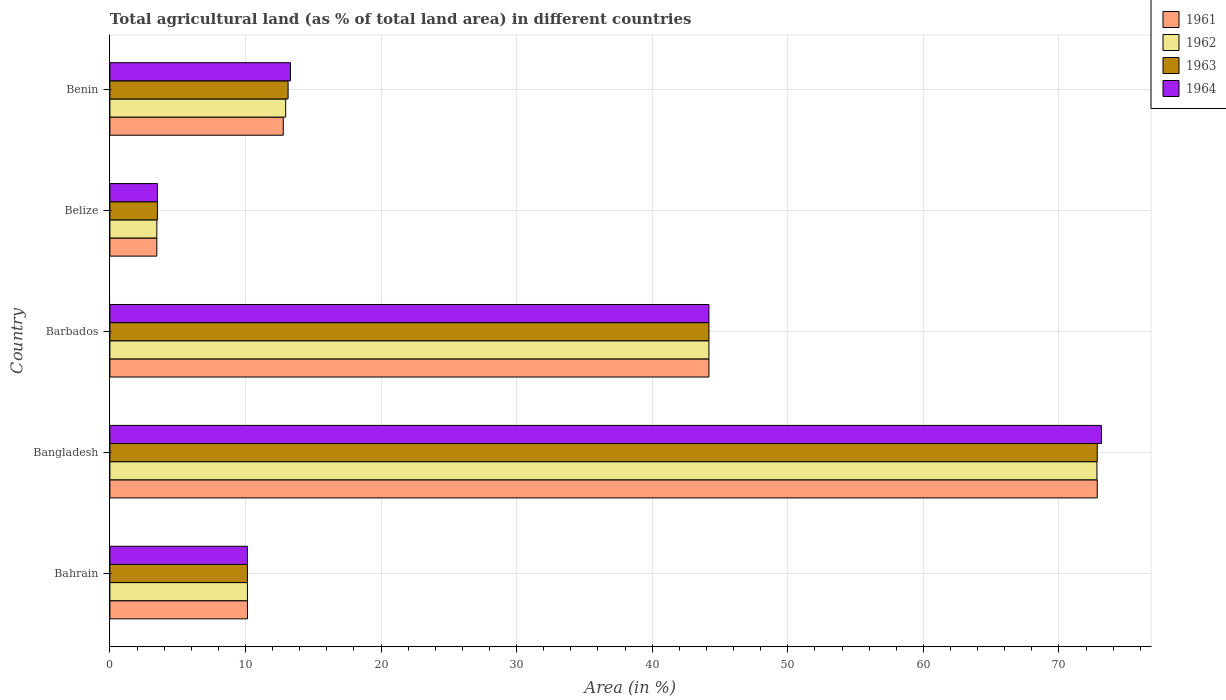Are the number of bars per tick equal to the number of legend labels?
Your answer should be compact. Yes. How many bars are there on the 3rd tick from the top?
Ensure brevity in your answer.  4. How many bars are there on the 3rd tick from the bottom?
Your answer should be compact. 4. What is the label of the 5th group of bars from the top?
Keep it short and to the point. Bahrain. In how many cases, is the number of bars for a given country not equal to the number of legend labels?
Give a very brief answer. 0. What is the percentage of agricultural land in 1962 in Belize?
Ensure brevity in your answer.  3.46. Across all countries, what is the maximum percentage of agricultural land in 1963?
Offer a terse response. 72.83. Across all countries, what is the minimum percentage of agricultural land in 1963?
Keep it short and to the point. 3.51. In which country was the percentage of agricultural land in 1964 minimum?
Offer a very short reply. Belize. What is the total percentage of agricultural land in 1964 in the graph?
Provide a succinct answer. 144.29. What is the difference between the percentage of agricultural land in 1962 in Bangladesh and that in Benin?
Provide a succinct answer. 59.84. What is the difference between the percentage of agricultural land in 1961 in Bahrain and the percentage of agricultural land in 1964 in Benin?
Your answer should be compact. -3.18. What is the average percentage of agricultural land in 1962 per country?
Your answer should be compact. 28.71. What is the difference between the percentage of agricultural land in 1962 and percentage of agricultural land in 1964 in Bahrain?
Make the answer very short. 0. What is the ratio of the percentage of agricultural land in 1964 in Bangladesh to that in Belize?
Ensure brevity in your answer.  20.85. Is the percentage of agricultural land in 1964 in Bangladesh less than that in Barbados?
Provide a short and direct response. No. Is the difference between the percentage of agricultural land in 1962 in Bahrain and Belize greater than the difference between the percentage of agricultural land in 1964 in Bahrain and Belize?
Offer a terse response. Yes. What is the difference between the highest and the second highest percentage of agricultural land in 1964?
Offer a terse response. 28.95. What is the difference between the highest and the lowest percentage of agricultural land in 1964?
Provide a succinct answer. 69.63. In how many countries, is the percentage of agricultural land in 1962 greater than the average percentage of agricultural land in 1962 taken over all countries?
Keep it short and to the point. 2. What does the 1st bar from the bottom in Barbados represents?
Ensure brevity in your answer.  1961. Is it the case that in every country, the sum of the percentage of agricultural land in 1962 and percentage of agricultural land in 1963 is greater than the percentage of agricultural land in 1961?
Keep it short and to the point. Yes. What is the difference between two consecutive major ticks on the X-axis?
Provide a succinct answer. 10. Does the graph contain any zero values?
Keep it short and to the point. No. Where does the legend appear in the graph?
Provide a short and direct response. Top right. How are the legend labels stacked?
Give a very brief answer. Vertical. What is the title of the graph?
Ensure brevity in your answer.  Total agricultural land (as % of total land area) in different countries. Does "1964" appear as one of the legend labels in the graph?
Provide a succinct answer. Yes. What is the label or title of the X-axis?
Offer a very short reply. Area (in %). What is the Area (in %) of 1961 in Bahrain?
Your answer should be very brief. 10.14. What is the Area (in %) of 1962 in Bahrain?
Ensure brevity in your answer.  10.14. What is the Area (in %) of 1963 in Bahrain?
Provide a succinct answer. 10.14. What is the Area (in %) of 1964 in Bahrain?
Your answer should be very brief. 10.14. What is the Area (in %) of 1961 in Bangladesh?
Make the answer very short. 72.83. What is the Area (in %) of 1962 in Bangladesh?
Provide a succinct answer. 72.8. What is the Area (in %) of 1963 in Bangladesh?
Give a very brief answer. 72.83. What is the Area (in %) in 1964 in Bangladesh?
Provide a succinct answer. 73.14. What is the Area (in %) of 1961 in Barbados?
Make the answer very short. 44.19. What is the Area (in %) of 1962 in Barbados?
Keep it short and to the point. 44.19. What is the Area (in %) in 1963 in Barbados?
Offer a terse response. 44.19. What is the Area (in %) of 1964 in Barbados?
Your answer should be compact. 44.19. What is the Area (in %) of 1961 in Belize?
Give a very brief answer. 3.46. What is the Area (in %) in 1962 in Belize?
Offer a terse response. 3.46. What is the Area (in %) of 1963 in Belize?
Provide a short and direct response. 3.51. What is the Area (in %) of 1964 in Belize?
Give a very brief answer. 3.51. What is the Area (in %) in 1961 in Benin?
Your response must be concise. 12.79. What is the Area (in %) in 1962 in Benin?
Make the answer very short. 12.97. What is the Area (in %) in 1963 in Benin?
Your answer should be compact. 13.14. What is the Area (in %) in 1964 in Benin?
Make the answer very short. 13.32. Across all countries, what is the maximum Area (in %) in 1961?
Your answer should be very brief. 72.83. Across all countries, what is the maximum Area (in %) of 1962?
Your response must be concise. 72.8. Across all countries, what is the maximum Area (in %) of 1963?
Offer a terse response. 72.83. Across all countries, what is the maximum Area (in %) of 1964?
Provide a short and direct response. 73.14. Across all countries, what is the minimum Area (in %) of 1961?
Your answer should be very brief. 3.46. Across all countries, what is the minimum Area (in %) of 1962?
Offer a terse response. 3.46. Across all countries, what is the minimum Area (in %) in 1963?
Give a very brief answer. 3.51. Across all countries, what is the minimum Area (in %) of 1964?
Ensure brevity in your answer.  3.51. What is the total Area (in %) of 1961 in the graph?
Keep it short and to the point. 143.41. What is the total Area (in %) of 1962 in the graph?
Provide a succinct answer. 143.56. What is the total Area (in %) in 1963 in the graph?
Offer a very short reply. 143.81. What is the total Area (in %) in 1964 in the graph?
Provide a succinct answer. 144.29. What is the difference between the Area (in %) of 1961 in Bahrain and that in Bangladesh?
Provide a short and direct response. -62.68. What is the difference between the Area (in %) of 1962 in Bahrain and that in Bangladesh?
Offer a very short reply. -62.66. What is the difference between the Area (in %) in 1963 in Bahrain and that in Bangladesh?
Offer a very short reply. -62.68. What is the difference between the Area (in %) in 1964 in Bahrain and that in Bangladesh?
Give a very brief answer. -62.99. What is the difference between the Area (in %) in 1961 in Bahrain and that in Barbados?
Give a very brief answer. -34.04. What is the difference between the Area (in %) in 1962 in Bahrain and that in Barbados?
Keep it short and to the point. -34.04. What is the difference between the Area (in %) of 1963 in Bahrain and that in Barbados?
Your answer should be compact. -34.04. What is the difference between the Area (in %) of 1964 in Bahrain and that in Barbados?
Give a very brief answer. -34.04. What is the difference between the Area (in %) in 1961 in Bahrain and that in Belize?
Ensure brevity in your answer.  6.68. What is the difference between the Area (in %) in 1962 in Bahrain and that in Belize?
Keep it short and to the point. 6.68. What is the difference between the Area (in %) in 1963 in Bahrain and that in Belize?
Your answer should be very brief. 6.64. What is the difference between the Area (in %) of 1964 in Bahrain and that in Belize?
Ensure brevity in your answer.  6.64. What is the difference between the Area (in %) in 1961 in Bahrain and that in Benin?
Your response must be concise. -2.64. What is the difference between the Area (in %) of 1962 in Bahrain and that in Benin?
Your response must be concise. -2.82. What is the difference between the Area (in %) of 1963 in Bahrain and that in Benin?
Offer a terse response. -3. What is the difference between the Area (in %) in 1964 in Bahrain and that in Benin?
Provide a short and direct response. -3.18. What is the difference between the Area (in %) in 1961 in Bangladesh and that in Barbados?
Ensure brevity in your answer.  28.64. What is the difference between the Area (in %) in 1962 in Bangladesh and that in Barbados?
Offer a terse response. 28.62. What is the difference between the Area (in %) in 1963 in Bangladesh and that in Barbados?
Your answer should be compact. 28.64. What is the difference between the Area (in %) in 1964 in Bangladesh and that in Barbados?
Offer a very short reply. 28.95. What is the difference between the Area (in %) of 1961 in Bangladesh and that in Belize?
Your answer should be compact. 69.36. What is the difference between the Area (in %) in 1962 in Bangladesh and that in Belize?
Your response must be concise. 69.34. What is the difference between the Area (in %) in 1963 in Bangladesh and that in Belize?
Offer a terse response. 69.32. What is the difference between the Area (in %) in 1964 in Bangladesh and that in Belize?
Keep it short and to the point. 69.63. What is the difference between the Area (in %) of 1961 in Bangladesh and that in Benin?
Offer a terse response. 60.04. What is the difference between the Area (in %) of 1962 in Bangladesh and that in Benin?
Your answer should be very brief. 59.84. What is the difference between the Area (in %) in 1963 in Bangladesh and that in Benin?
Make the answer very short. 59.68. What is the difference between the Area (in %) of 1964 in Bangladesh and that in Benin?
Keep it short and to the point. 59.81. What is the difference between the Area (in %) of 1961 in Barbados and that in Belize?
Your answer should be compact. 40.72. What is the difference between the Area (in %) in 1962 in Barbados and that in Belize?
Make the answer very short. 40.72. What is the difference between the Area (in %) of 1963 in Barbados and that in Belize?
Your answer should be compact. 40.68. What is the difference between the Area (in %) of 1964 in Barbados and that in Belize?
Your response must be concise. 40.68. What is the difference between the Area (in %) in 1961 in Barbados and that in Benin?
Your answer should be very brief. 31.4. What is the difference between the Area (in %) in 1962 in Barbados and that in Benin?
Offer a terse response. 31.22. What is the difference between the Area (in %) in 1963 in Barbados and that in Benin?
Your answer should be very brief. 31.04. What is the difference between the Area (in %) in 1964 in Barbados and that in Benin?
Provide a succinct answer. 30.87. What is the difference between the Area (in %) of 1961 in Belize and that in Benin?
Your response must be concise. -9.32. What is the difference between the Area (in %) in 1962 in Belize and that in Benin?
Your answer should be compact. -9.5. What is the difference between the Area (in %) of 1963 in Belize and that in Benin?
Provide a succinct answer. -9.64. What is the difference between the Area (in %) in 1964 in Belize and that in Benin?
Offer a terse response. -9.81. What is the difference between the Area (in %) of 1961 in Bahrain and the Area (in %) of 1962 in Bangladesh?
Provide a short and direct response. -62.66. What is the difference between the Area (in %) in 1961 in Bahrain and the Area (in %) in 1963 in Bangladesh?
Your answer should be compact. -62.68. What is the difference between the Area (in %) of 1961 in Bahrain and the Area (in %) of 1964 in Bangladesh?
Make the answer very short. -62.99. What is the difference between the Area (in %) of 1962 in Bahrain and the Area (in %) of 1963 in Bangladesh?
Keep it short and to the point. -62.68. What is the difference between the Area (in %) in 1962 in Bahrain and the Area (in %) in 1964 in Bangladesh?
Provide a succinct answer. -62.99. What is the difference between the Area (in %) of 1963 in Bahrain and the Area (in %) of 1964 in Bangladesh?
Offer a very short reply. -62.99. What is the difference between the Area (in %) in 1961 in Bahrain and the Area (in %) in 1962 in Barbados?
Provide a succinct answer. -34.04. What is the difference between the Area (in %) of 1961 in Bahrain and the Area (in %) of 1963 in Barbados?
Ensure brevity in your answer.  -34.04. What is the difference between the Area (in %) in 1961 in Bahrain and the Area (in %) in 1964 in Barbados?
Provide a succinct answer. -34.04. What is the difference between the Area (in %) in 1962 in Bahrain and the Area (in %) in 1963 in Barbados?
Provide a short and direct response. -34.04. What is the difference between the Area (in %) of 1962 in Bahrain and the Area (in %) of 1964 in Barbados?
Offer a very short reply. -34.04. What is the difference between the Area (in %) in 1963 in Bahrain and the Area (in %) in 1964 in Barbados?
Make the answer very short. -34.04. What is the difference between the Area (in %) of 1961 in Bahrain and the Area (in %) of 1962 in Belize?
Offer a terse response. 6.68. What is the difference between the Area (in %) in 1961 in Bahrain and the Area (in %) in 1963 in Belize?
Make the answer very short. 6.64. What is the difference between the Area (in %) in 1961 in Bahrain and the Area (in %) in 1964 in Belize?
Provide a succinct answer. 6.64. What is the difference between the Area (in %) in 1962 in Bahrain and the Area (in %) in 1963 in Belize?
Give a very brief answer. 6.64. What is the difference between the Area (in %) in 1962 in Bahrain and the Area (in %) in 1964 in Belize?
Ensure brevity in your answer.  6.64. What is the difference between the Area (in %) in 1963 in Bahrain and the Area (in %) in 1964 in Belize?
Make the answer very short. 6.64. What is the difference between the Area (in %) of 1961 in Bahrain and the Area (in %) of 1962 in Benin?
Make the answer very short. -2.82. What is the difference between the Area (in %) of 1961 in Bahrain and the Area (in %) of 1963 in Benin?
Your answer should be very brief. -3. What is the difference between the Area (in %) in 1961 in Bahrain and the Area (in %) in 1964 in Benin?
Make the answer very short. -3.18. What is the difference between the Area (in %) of 1962 in Bahrain and the Area (in %) of 1963 in Benin?
Keep it short and to the point. -3. What is the difference between the Area (in %) of 1962 in Bahrain and the Area (in %) of 1964 in Benin?
Provide a short and direct response. -3.18. What is the difference between the Area (in %) of 1963 in Bahrain and the Area (in %) of 1964 in Benin?
Make the answer very short. -3.18. What is the difference between the Area (in %) of 1961 in Bangladesh and the Area (in %) of 1962 in Barbados?
Make the answer very short. 28.64. What is the difference between the Area (in %) in 1961 in Bangladesh and the Area (in %) in 1963 in Barbados?
Your answer should be compact. 28.64. What is the difference between the Area (in %) in 1961 in Bangladesh and the Area (in %) in 1964 in Barbados?
Your answer should be very brief. 28.64. What is the difference between the Area (in %) of 1962 in Bangladesh and the Area (in %) of 1963 in Barbados?
Make the answer very short. 28.62. What is the difference between the Area (in %) in 1962 in Bangladesh and the Area (in %) in 1964 in Barbados?
Provide a short and direct response. 28.62. What is the difference between the Area (in %) of 1963 in Bangladesh and the Area (in %) of 1964 in Barbados?
Provide a short and direct response. 28.64. What is the difference between the Area (in %) in 1961 in Bangladesh and the Area (in %) in 1962 in Belize?
Provide a short and direct response. 69.36. What is the difference between the Area (in %) of 1961 in Bangladesh and the Area (in %) of 1963 in Belize?
Keep it short and to the point. 69.32. What is the difference between the Area (in %) in 1961 in Bangladesh and the Area (in %) in 1964 in Belize?
Keep it short and to the point. 69.32. What is the difference between the Area (in %) in 1962 in Bangladesh and the Area (in %) in 1963 in Belize?
Offer a very short reply. 69.3. What is the difference between the Area (in %) of 1962 in Bangladesh and the Area (in %) of 1964 in Belize?
Give a very brief answer. 69.3. What is the difference between the Area (in %) of 1963 in Bangladesh and the Area (in %) of 1964 in Belize?
Your answer should be very brief. 69.32. What is the difference between the Area (in %) in 1961 in Bangladesh and the Area (in %) in 1962 in Benin?
Offer a terse response. 59.86. What is the difference between the Area (in %) of 1961 in Bangladesh and the Area (in %) of 1963 in Benin?
Provide a succinct answer. 59.68. What is the difference between the Area (in %) in 1961 in Bangladesh and the Area (in %) in 1964 in Benin?
Offer a terse response. 59.51. What is the difference between the Area (in %) in 1962 in Bangladesh and the Area (in %) in 1963 in Benin?
Provide a short and direct response. 59.66. What is the difference between the Area (in %) of 1962 in Bangladesh and the Area (in %) of 1964 in Benin?
Your answer should be very brief. 59.48. What is the difference between the Area (in %) in 1963 in Bangladesh and the Area (in %) in 1964 in Benin?
Offer a terse response. 59.51. What is the difference between the Area (in %) in 1961 in Barbados and the Area (in %) in 1962 in Belize?
Your response must be concise. 40.72. What is the difference between the Area (in %) in 1961 in Barbados and the Area (in %) in 1963 in Belize?
Offer a terse response. 40.68. What is the difference between the Area (in %) in 1961 in Barbados and the Area (in %) in 1964 in Belize?
Make the answer very short. 40.68. What is the difference between the Area (in %) in 1962 in Barbados and the Area (in %) in 1963 in Belize?
Offer a very short reply. 40.68. What is the difference between the Area (in %) in 1962 in Barbados and the Area (in %) in 1964 in Belize?
Your response must be concise. 40.68. What is the difference between the Area (in %) in 1963 in Barbados and the Area (in %) in 1964 in Belize?
Your answer should be very brief. 40.68. What is the difference between the Area (in %) in 1961 in Barbados and the Area (in %) in 1962 in Benin?
Your answer should be compact. 31.22. What is the difference between the Area (in %) in 1961 in Barbados and the Area (in %) in 1963 in Benin?
Your answer should be very brief. 31.04. What is the difference between the Area (in %) in 1961 in Barbados and the Area (in %) in 1964 in Benin?
Offer a terse response. 30.87. What is the difference between the Area (in %) in 1962 in Barbados and the Area (in %) in 1963 in Benin?
Make the answer very short. 31.04. What is the difference between the Area (in %) of 1962 in Barbados and the Area (in %) of 1964 in Benin?
Give a very brief answer. 30.87. What is the difference between the Area (in %) in 1963 in Barbados and the Area (in %) in 1964 in Benin?
Your answer should be very brief. 30.87. What is the difference between the Area (in %) of 1961 in Belize and the Area (in %) of 1962 in Benin?
Your response must be concise. -9.5. What is the difference between the Area (in %) in 1961 in Belize and the Area (in %) in 1963 in Benin?
Provide a short and direct response. -9.68. What is the difference between the Area (in %) of 1961 in Belize and the Area (in %) of 1964 in Benin?
Your response must be concise. -9.86. What is the difference between the Area (in %) in 1962 in Belize and the Area (in %) in 1963 in Benin?
Provide a short and direct response. -9.68. What is the difference between the Area (in %) of 1962 in Belize and the Area (in %) of 1964 in Benin?
Offer a very short reply. -9.86. What is the difference between the Area (in %) in 1963 in Belize and the Area (in %) in 1964 in Benin?
Offer a very short reply. -9.81. What is the average Area (in %) of 1961 per country?
Your answer should be compact. 28.68. What is the average Area (in %) of 1962 per country?
Provide a short and direct response. 28.71. What is the average Area (in %) in 1963 per country?
Provide a succinct answer. 28.76. What is the average Area (in %) of 1964 per country?
Your answer should be compact. 28.86. What is the difference between the Area (in %) in 1961 and Area (in %) in 1962 in Bahrain?
Make the answer very short. 0. What is the difference between the Area (in %) of 1962 and Area (in %) of 1963 in Bahrain?
Give a very brief answer. 0. What is the difference between the Area (in %) in 1963 and Area (in %) in 1964 in Bahrain?
Keep it short and to the point. 0. What is the difference between the Area (in %) in 1961 and Area (in %) in 1962 in Bangladesh?
Offer a very short reply. 0.02. What is the difference between the Area (in %) of 1961 and Area (in %) of 1964 in Bangladesh?
Your answer should be very brief. -0.31. What is the difference between the Area (in %) of 1962 and Area (in %) of 1963 in Bangladesh?
Make the answer very short. -0.02. What is the difference between the Area (in %) in 1962 and Area (in %) in 1964 in Bangladesh?
Provide a succinct answer. -0.33. What is the difference between the Area (in %) of 1963 and Area (in %) of 1964 in Bangladesh?
Provide a succinct answer. -0.31. What is the difference between the Area (in %) of 1963 and Area (in %) of 1964 in Barbados?
Your response must be concise. 0. What is the difference between the Area (in %) in 1961 and Area (in %) in 1962 in Belize?
Your answer should be very brief. 0. What is the difference between the Area (in %) of 1961 and Area (in %) of 1963 in Belize?
Offer a very short reply. -0.04. What is the difference between the Area (in %) of 1961 and Area (in %) of 1964 in Belize?
Your answer should be very brief. -0.04. What is the difference between the Area (in %) of 1962 and Area (in %) of 1963 in Belize?
Give a very brief answer. -0.04. What is the difference between the Area (in %) in 1962 and Area (in %) in 1964 in Belize?
Provide a succinct answer. -0.04. What is the difference between the Area (in %) of 1963 and Area (in %) of 1964 in Belize?
Give a very brief answer. 0. What is the difference between the Area (in %) in 1961 and Area (in %) in 1962 in Benin?
Provide a short and direct response. -0.18. What is the difference between the Area (in %) of 1961 and Area (in %) of 1963 in Benin?
Keep it short and to the point. -0.35. What is the difference between the Area (in %) of 1961 and Area (in %) of 1964 in Benin?
Give a very brief answer. -0.53. What is the difference between the Area (in %) of 1962 and Area (in %) of 1963 in Benin?
Provide a short and direct response. -0.18. What is the difference between the Area (in %) in 1962 and Area (in %) in 1964 in Benin?
Provide a short and direct response. -0.35. What is the difference between the Area (in %) in 1963 and Area (in %) in 1964 in Benin?
Your response must be concise. -0.18. What is the ratio of the Area (in %) in 1961 in Bahrain to that in Bangladesh?
Your response must be concise. 0.14. What is the ratio of the Area (in %) of 1962 in Bahrain to that in Bangladesh?
Your response must be concise. 0.14. What is the ratio of the Area (in %) in 1963 in Bahrain to that in Bangladesh?
Offer a very short reply. 0.14. What is the ratio of the Area (in %) of 1964 in Bahrain to that in Bangladesh?
Your answer should be compact. 0.14. What is the ratio of the Area (in %) in 1961 in Bahrain to that in Barbados?
Offer a terse response. 0.23. What is the ratio of the Area (in %) of 1962 in Bahrain to that in Barbados?
Your answer should be compact. 0.23. What is the ratio of the Area (in %) of 1963 in Bahrain to that in Barbados?
Provide a succinct answer. 0.23. What is the ratio of the Area (in %) in 1964 in Bahrain to that in Barbados?
Your response must be concise. 0.23. What is the ratio of the Area (in %) in 1961 in Bahrain to that in Belize?
Provide a short and direct response. 2.93. What is the ratio of the Area (in %) in 1962 in Bahrain to that in Belize?
Offer a very short reply. 2.93. What is the ratio of the Area (in %) in 1963 in Bahrain to that in Belize?
Offer a very short reply. 2.89. What is the ratio of the Area (in %) of 1964 in Bahrain to that in Belize?
Keep it short and to the point. 2.89. What is the ratio of the Area (in %) of 1961 in Bahrain to that in Benin?
Offer a very short reply. 0.79. What is the ratio of the Area (in %) of 1962 in Bahrain to that in Benin?
Your answer should be very brief. 0.78. What is the ratio of the Area (in %) in 1963 in Bahrain to that in Benin?
Provide a short and direct response. 0.77. What is the ratio of the Area (in %) of 1964 in Bahrain to that in Benin?
Provide a succinct answer. 0.76. What is the ratio of the Area (in %) in 1961 in Bangladesh to that in Barbados?
Your answer should be compact. 1.65. What is the ratio of the Area (in %) in 1962 in Bangladesh to that in Barbados?
Ensure brevity in your answer.  1.65. What is the ratio of the Area (in %) in 1963 in Bangladesh to that in Barbados?
Ensure brevity in your answer.  1.65. What is the ratio of the Area (in %) of 1964 in Bangladesh to that in Barbados?
Your answer should be very brief. 1.66. What is the ratio of the Area (in %) of 1961 in Bangladesh to that in Belize?
Your answer should be very brief. 21.03. What is the ratio of the Area (in %) of 1962 in Bangladesh to that in Belize?
Make the answer very short. 21.02. What is the ratio of the Area (in %) in 1963 in Bangladesh to that in Belize?
Your answer should be compact. 20.77. What is the ratio of the Area (in %) of 1964 in Bangladesh to that in Belize?
Give a very brief answer. 20.85. What is the ratio of the Area (in %) in 1961 in Bangladesh to that in Benin?
Offer a terse response. 5.69. What is the ratio of the Area (in %) in 1962 in Bangladesh to that in Benin?
Ensure brevity in your answer.  5.62. What is the ratio of the Area (in %) in 1963 in Bangladesh to that in Benin?
Keep it short and to the point. 5.54. What is the ratio of the Area (in %) of 1964 in Bangladesh to that in Benin?
Offer a very short reply. 5.49. What is the ratio of the Area (in %) of 1961 in Barbados to that in Belize?
Provide a succinct answer. 12.76. What is the ratio of the Area (in %) in 1962 in Barbados to that in Belize?
Provide a short and direct response. 12.76. What is the ratio of the Area (in %) in 1963 in Barbados to that in Belize?
Your answer should be very brief. 12.6. What is the ratio of the Area (in %) in 1964 in Barbados to that in Belize?
Keep it short and to the point. 12.6. What is the ratio of the Area (in %) of 1961 in Barbados to that in Benin?
Your response must be concise. 3.46. What is the ratio of the Area (in %) in 1962 in Barbados to that in Benin?
Your response must be concise. 3.41. What is the ratio of the Area (in %) in 1963 in Barbados to that in Benin?
Provide a succinct answer. 3.36. What is the ratio of the Area (in %) in 1964 in Barbados to that in Benin?
Offer a very short reply. 3.32. What is the ratio of the Area (in %) of 1961 in Belize to that in Benin?
Provide a succinct answer. 0.27. What is the ratio of the Area (in %) of 1962 in Belize to that in Benin?
Offer a terse response. 0.27. What is the ratio of the Area (in %) of 1963 in Belize to that in Benin?
Provide a short and direct response. 0.27. What is the ratio of the Area (in %) of 1964 in Belize to that in Benin?
Provide a succinct answer. 0.26. What is the difference between the highest and the second highest Area (in %) of 1961?
Ensure brevity in your answer.  28.64. What is the difference between the highest and the second highest Area (in %) in 1962?
Your answer should be very brief. 28.62. What is the difference between the highest and the second highest Area (in %) of 1963?
Give a very brief answer. 28.64. What is the difference between the highest and the second highest Area (in %) of 1964?
Your answer should be compact. 28.95. What is the difference between the highest and the lowest Area (in %) in 1961?
Provide a succinct answer. 69.36. What is the difference between the highest and the lowest Area (in %) of 1962?
Offer a very short reply. 69.34. What is the difference between the highest and the lowest Area (in %) in 1963?
Provide a succinct answer. 69.32. What is the difference between the highest and the lowest Area (in %) of 1964?
Provide a succinct answer. 69.63. 